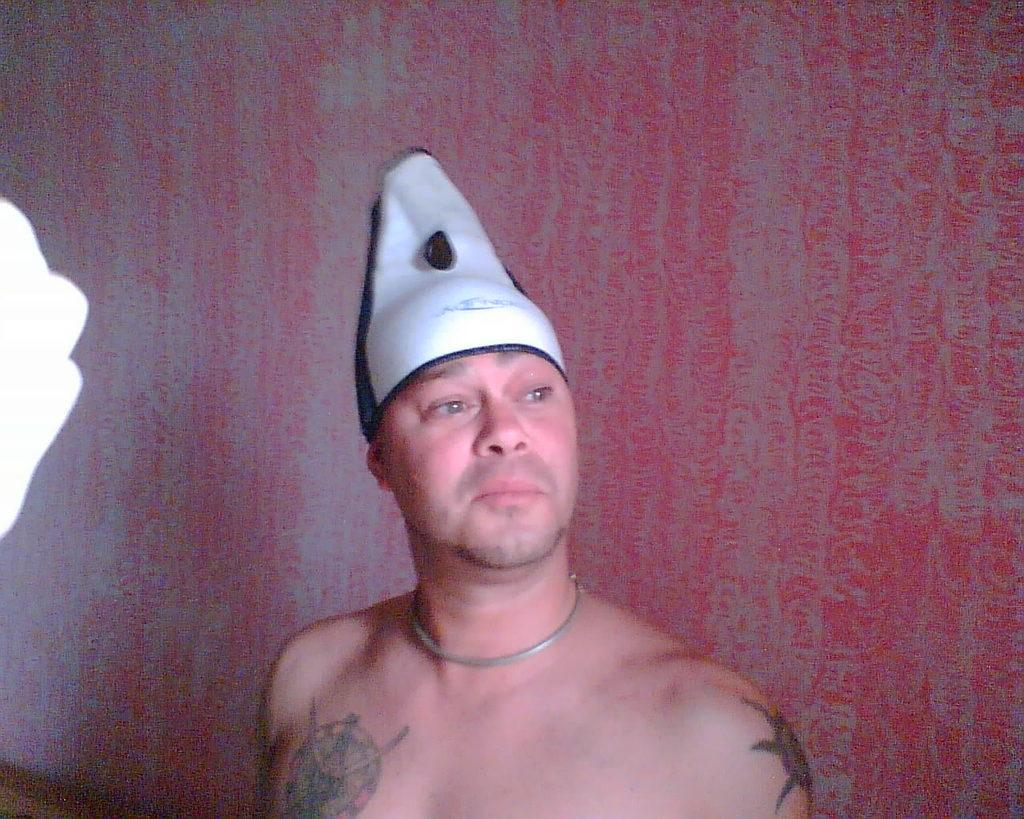Who is present in the image? There is a man in the image. What is the man wearing on his head? The man is wearing a white cap. Are there any visible markings on the man's body? Yes, the man has tattoos on his body. What color can be seen in the background of the image? There is a red color visible in the background of the image. Can you tell me how many giraffes are in the picture? There are no giraffes present in the image; it features a man with a white cap and tattoos. What kind of trouble is the man causing in the image? There is no indication of trouble or any negative actions in the image; the man is simply wearing a white cap and has tattoos. 